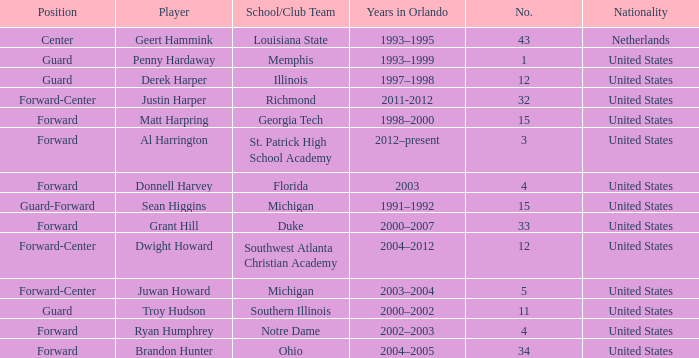What school did Dwight Howard play for Southwest Atlanta Christian Academy. 